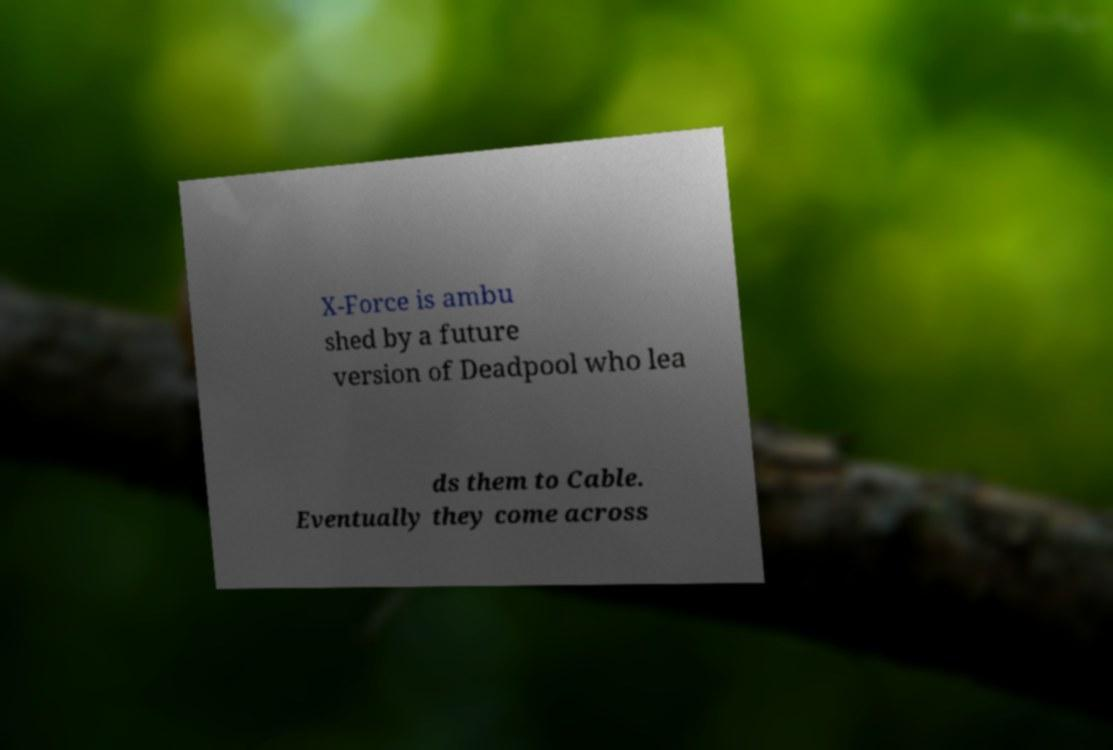What messages or text are displayed in this image? I need them in a readable, typed format. X-Force is ambu shed by a future version of Deadpool who lea ds them to Cable. Eventually they come across 